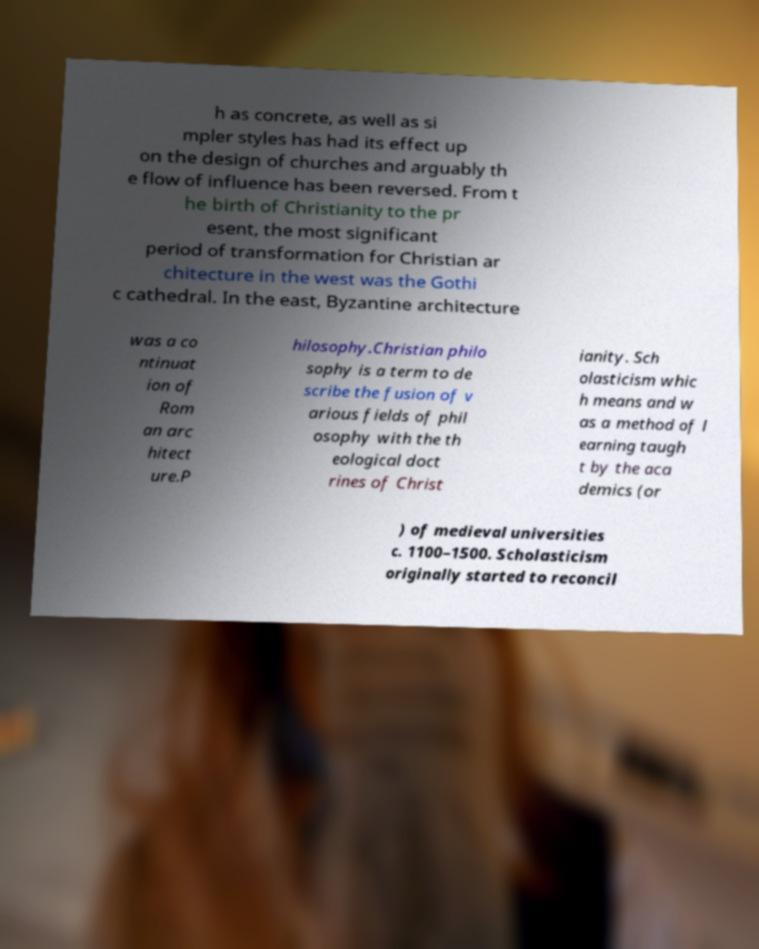Could you extract and type out the text from this image? h as concrete, as well as si mpler styles has had its effect up on the design of churches and arguably th e flow of influence has been reversed. From t he birth of Christianity to the pr esent, the most significant period of transformation for Christian ar chitecture in the west was the Gothi c cathedral. In the east, Byzantine architecture was a co ntinuat ion of Rom an arc hitect ure.P hilosophy.Christian philo sophy is a term to de scribe the fusion of v arious fields of phil osophy with the th eological doct rines of Christ ianity. Sch olasticism whic h means and w as a method of l earning taugh t by the aca demics (or ) of medieval universities c. 1100–1500. Scholasticism originally started to reconcil 